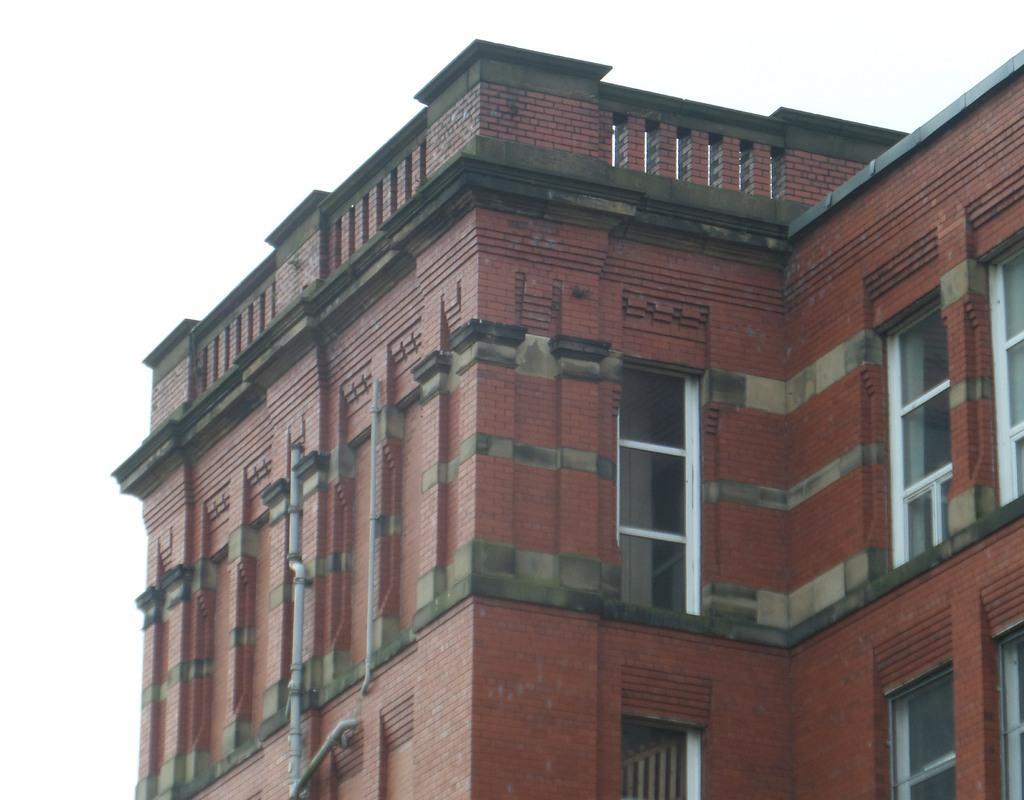Can you describe this image briefly? In this image we can see a building and it is having few windows. There is a white background in the image. There are few pipes attached to the building. 